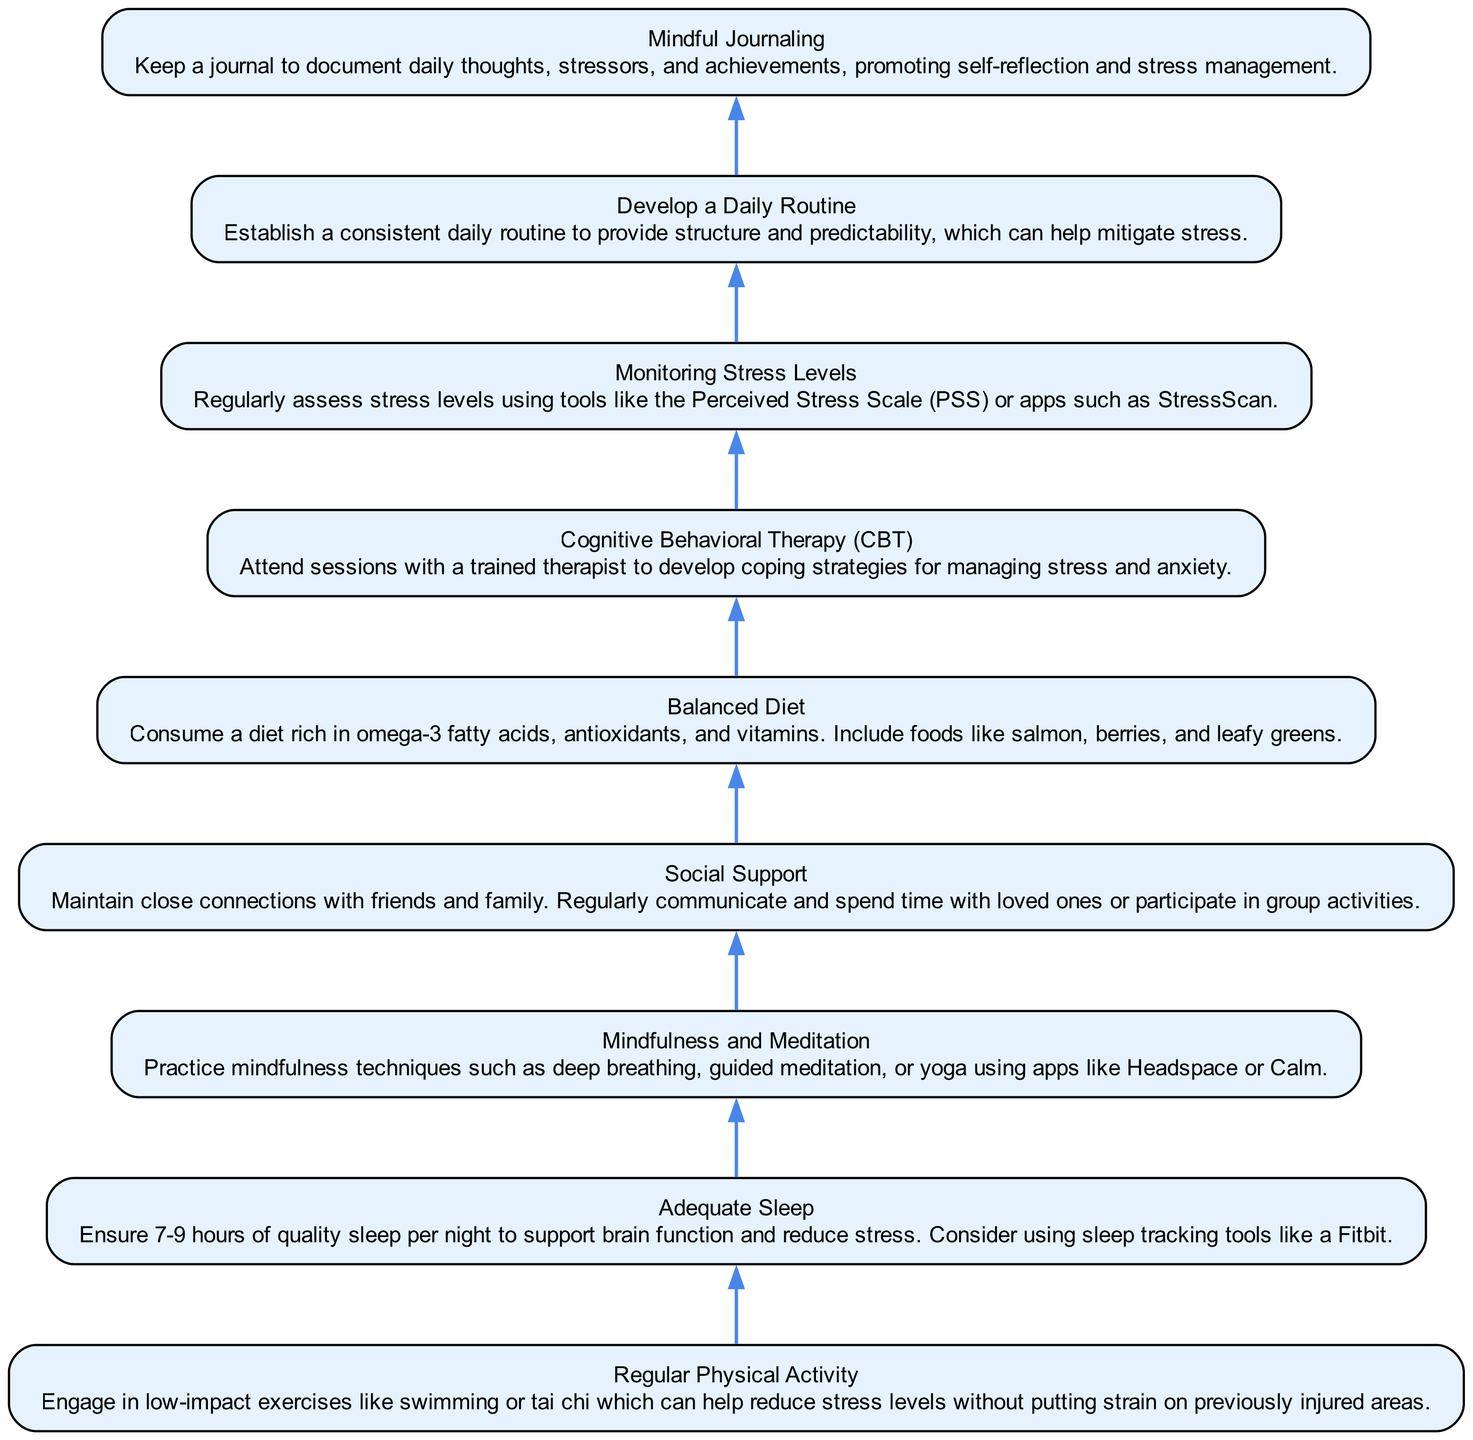What is the first step in managing stress levels? The first step in the flowchart is "Regular Physical Activity", which is at the bottom of the diagram. This indicates it is the initial action to take when addressing stress levels.
Answer: Regular Physical Activity How many nodes are present in the flowchart? By counting each of the elements listed in the data, we find there are 9 distinct nodes, corresponding to each step in the process of monitoring and managing stress levels.
Answer: 9 What comes after "Balanced Diet" in the flowchart? "Cognitive Behavioral Therapy (CBT)" directly follows "Balanced Diet", as the arrows indicate the flow from one step to the next.
Answer: Cognitive Behavioral Therapy (CBT) Which step focuses on community and relationships? The step that emphasizes community and maintaining relationships with others is "Social Support". This is designed to help manage stress through interpersonal connections.
Answer: Social Support What is the purpose of the "Monitoring Stress Levels" node? "Monitoring Stress Levels" serves the purpose of regularly assessing how much stress one is experiencing, using tools like the Perceived Stress Scale or stress assessment apps, helping track progress and needs for support.
Answer: Regularly assess stress levels How are "Mindfulness and Meditation" and "Mindful Journaling" related? Both "Mindfulness and Meditation" and "Mindful Journaling" are focused on self-reflection and mental well-being. They serve as strategies for stress reduction, complementing each other within the overall process.
Answer: Complementary strategies for self-reflection Which two steps are critical for physical health? "Regular Physical Activity" and "Balanced Diet" are the two steps critical for maintaining physical health, contributing directly to stress management through physical conditions.
Answer: Regular Physical Activity and Balanced Diet What does establishing a "Daily Routine" provide? A "Daily Routine" provides structure and predictability, which are essential for reducing stress, as illustrated in the flowchart.
Answer: Structure and predictability What is the last step in the flowchart? The last step in the flowchart is "Mindful Journaling", indicating it is a concluding action in the process of managing and understanding stress.
Answer: Mindful Journaling 